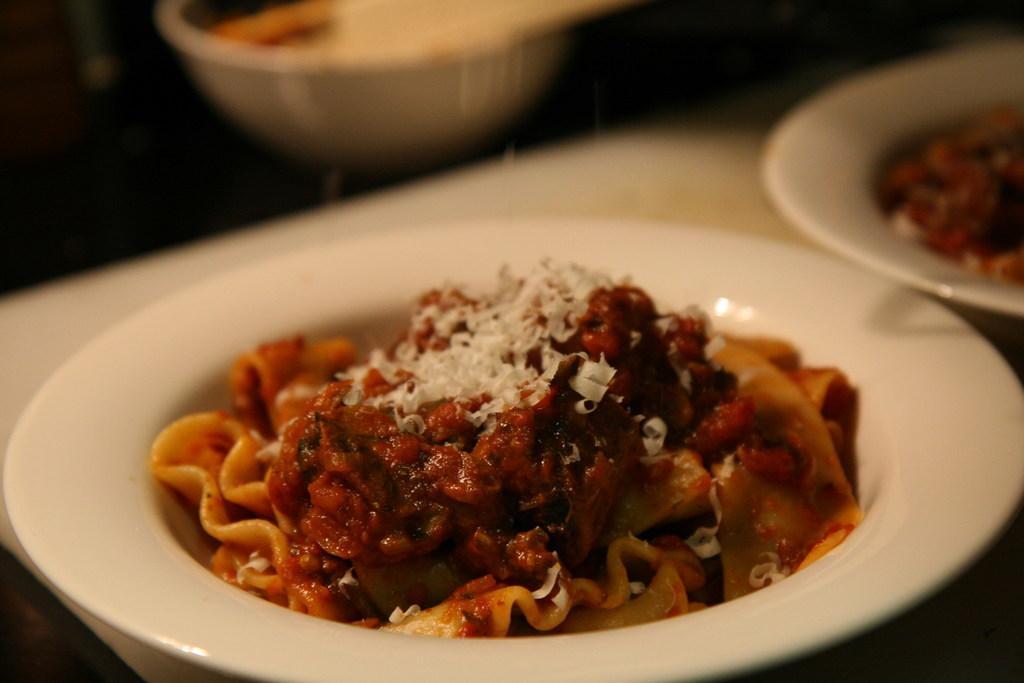In one or two sentences, can you explain what this image depicts? In this place we can see food. On the table we can see plates and bowl. 